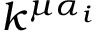<formula> <loc_0><loc_0><loc_500><loc_500>k ^ { \mu \alpha _ { i } }</formula> 